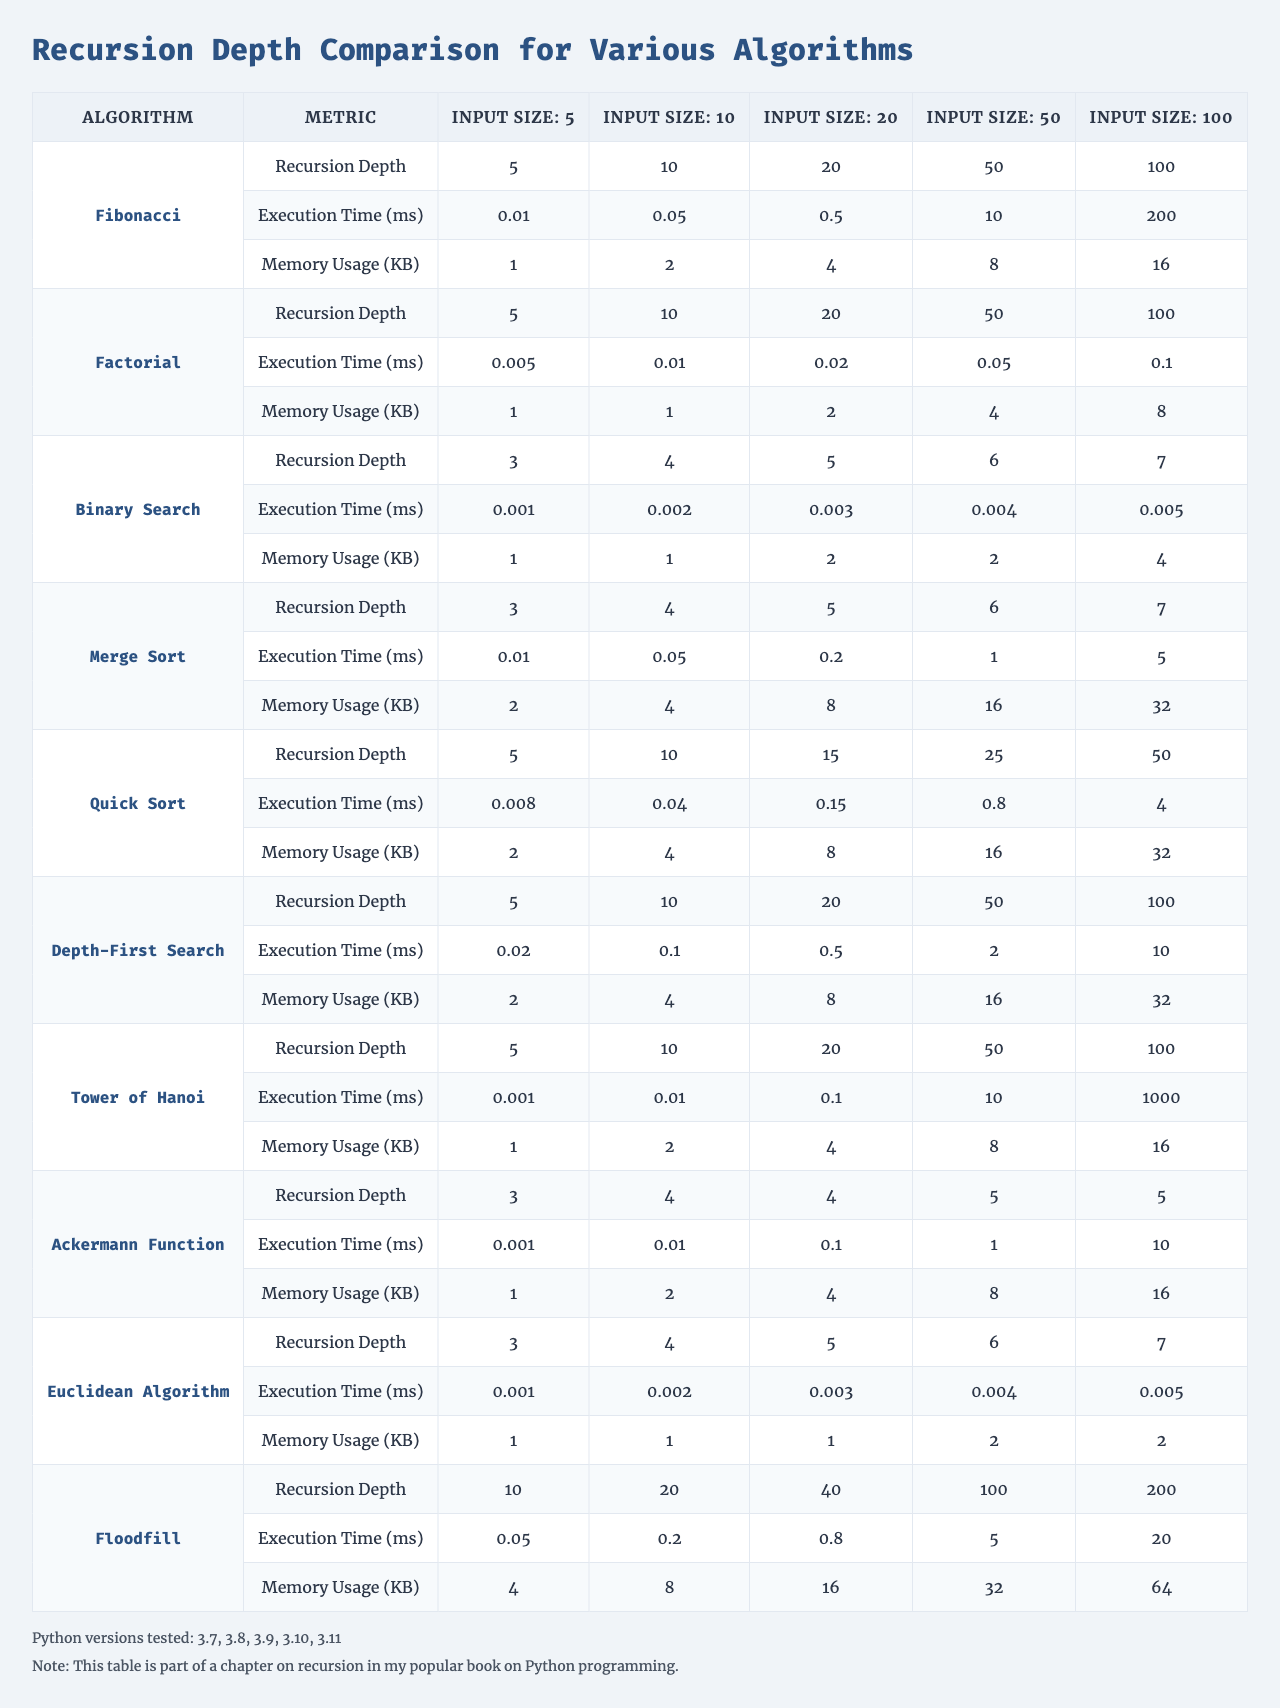What is the recursion depth for the Fibonacci algorithm with an input size of 100? Looking at the "Recursion Depth" row for the "Fibonacci" algorithm, the value for input size 100 is 100.
Answer: 100 What is the execution time for the Quick Sort algorithm when the input size is 10? In the "Execution Time (ms)" row for the "Quick Sort" algorithm, the value for input size 10 is 0.04 milliseconds.
Answer: 0.04 milliseconds Which algorithm has the highest recursion depth for an input size of 50? By comparing the "Recursion Depth" values for input size 50 across all algorithms, "Tower of Hanoi," "Depth-First Search," and "Fibonacci" all have a recursion depth of 100, which is the highest.
Answer: Tower of Hanoi, Depth-First Search, Fibonacci What is the average execution time for the Factorial algorithm across all input sizes? The execution times for the Factorial algorithm are [0.005, 0.01, 0.02, 0.05, 0.1]. Adding these gives a sum of 0.005 + 0.01 + 0.02 + 0.05 + 0.1 = 0.185 milliseconds. Dividing by 5 (the number of input sizes) gives an average execution time of 0.185 / 5 = 0.037 milliseconds.
Answer: 0.037 milliseconds Does the Memory Usage for the Euclidean Algorithm exceed 4 KB for any input size? By examining the "Memory Usage (KB)" values for the Euclidean Algorithm, we see it is 1 KB for input sizes 5, 10, 20, and 1 KB for both input sizes 50 and 100, therefore it does not exceed 4 KB for any size.
Answer: No Which algorithm shows a linear increase in execution time with increasing input size? Analyzing the execution times for each input size, "Binary Search" shows a steady increase from 0.001 to 0.005 milliseconds, suggesting a linear increase relative to the input size.
Answer: Binary Search What is the difference in memory usage between the Fibonacci and Factorial algorithms for an input size of 20? For the Fibonacci algorithm, memory usage at input size 20 is 4 KB, and for the Factorial algorithm, it is 2 KB. The difference is 4 - 2 = 2 KB.
Answer: 2 KB Which algorithm consumes the most memory at the largest input size? Comparing the "Memory Usage (KB)" values across all algorithms for the input size of 100, "Floodfill" consumes the most memory at 64 KB.
Answer: Floodfill What is the ratio of the maximum execution time for the Tower of Hanoi to that of the Merge Sort algorithm when input size is 50? The maximum execution time for Tower of Hanoi with input size 50 is 1000 ms, and for Merge Sort, it is 5 ms. Thus, the ratio is 1000 / 5 = 200.
Answer: 200 If we examine the recursion depths for input sizes 10 and 20, which algorithm has a smaller increase in depth? Looking at the "Recursion Depth" values for input sizes 10 and 20, Fibonacci's depth increases from 10 to 20 (a difference of 10), while Binary Search’s increases from 4 to 5 (a difference of 1). Hence, Binary Search has a smaller increase in depth.
Answer: Binary Search 